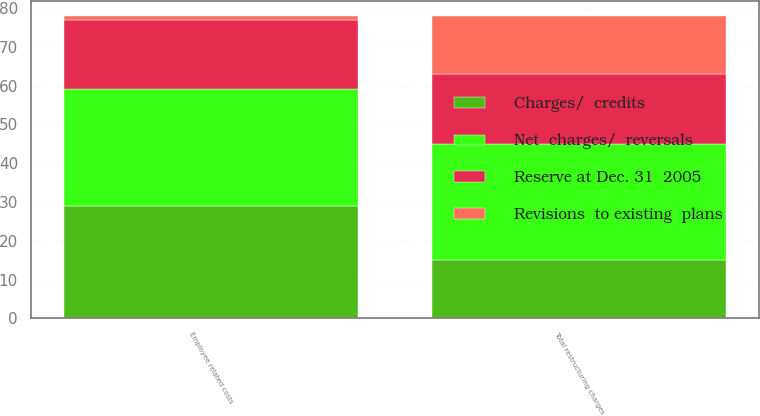Convert chart. <chart><loc_0><loc_0><loc_500><loc_500><stacked_bar_chart><ecel><fcel>Employee related costs<fcel>Total restructuring charges<nl><fcel>Reserve at Dec. 31  2005<fcel>18<fcel>18<nl><fcel>Net  charges/  reversals<fcel>30<fcel>30<nl><fcel>Revisions  to existing  plans<fcel>1<fcel>15<nl><fcel>Charges/  credits<fcel>29<fcel>15<nl></chart> 